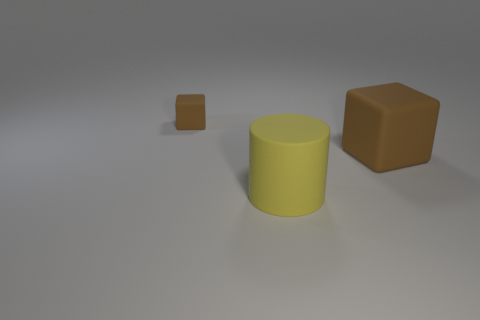If you had to guess, what material do you think the surface and objects are made of? Based on the visual cues, the surface resembles a matte texture, likely a type of non-reflective plastic or painted material. The objects, being matte as well, could also be made of a similar plastic or a type of polymer with a non-glossy finish. The shadows and lack of reflection support the hypothesis of matte surfaces for both the base and the objects. 